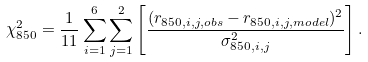<formula> <loc_0><loc_0><loc_500><loc_500>\chi _ { 8 5 0 } ^ { 2 } = \frac { 1 } { 1 1 } \sum _ { i = 1 } ^ { 6 } \sum _ { j = 1 } ^ { 2 } \left [ \frac { ( r _ { 8 5 0 , i , j , o b s } - r _ { 8 5 0 , i , j , m o d e l } ) ^ { 2 } } { \sigma _ { 8 5 0 , i , j } ^ { 2 } } \right ] .</formula> 